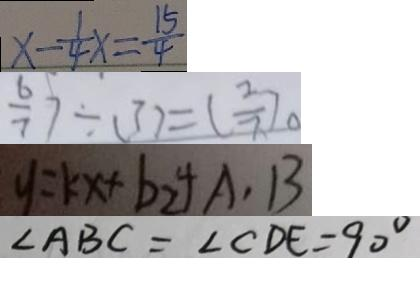Convert formula to latex. <formula><loc_0><loc_0><loc_500><loc_500>x - \frac { 1 } { 4 } x = \frac { 1 5 } { 4 } 
 \frac { 6 } { 7 } ) \div ( 3 ) = ( \frac { 2 } { 7 } ) 。 
 y = k x + b _ { 2 } + A , B 
 \angle A B C = \angle C D E = 9 0 ^ { \circ }</formula> 